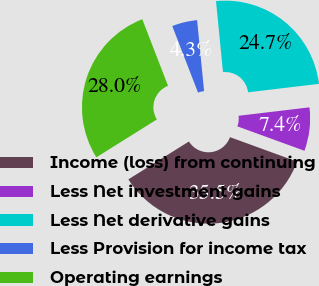<chart> <loc_0><loc_0><loc_500><loc_500><pie_chart><fcel>Income (loss) from continuing<fcel>Less Net investment gains<fcel>Less Net derivative gains<fcel>Less Provision for income tax<fcel>Operating earnings<nl><fcel>35.54%<fcel>7.44%<fcel>24.67%<fcel>4.32%<fcel>28.02%<nl></chart> 